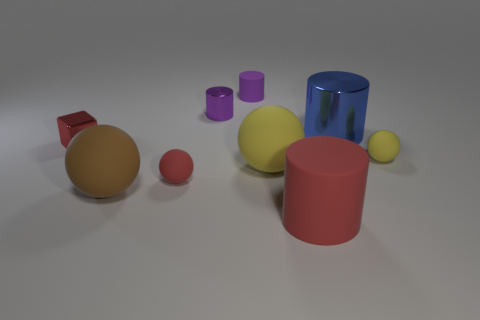Can you speculate on the possible purpose of this arrangement? The purpose of this arrangement isn't clear, but it could serve as a visual study of shapes, colors, and textures, or perhaps a demonstration in a 3D modeling or physics simulation software. 